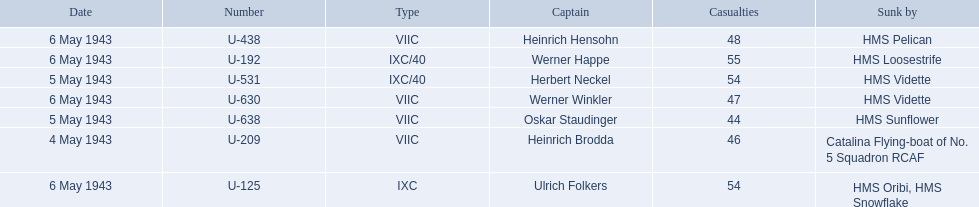Who are all of the captains? Heinrich Brodda, Oskar Staudinger, Herbert Neckel, Werner Happe, Ulrich Folkers, Werner Winkler, Heinrich Hensohn. What sunk each of the captains? Catalina Flying-boat of No. 5 Squadron RCAF, HMS Sunflower, HMS Vidette, HMS Loosestrife, HMS Oribi, HMS Snowflake, HMS Vidette, HMS Pelican. Which was sunk by the hms pelican? Heinrich Hensohn. 